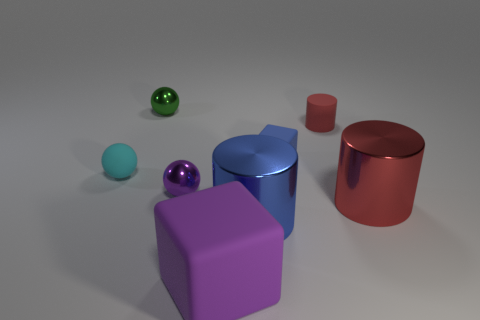Is the material of the large block the same as the small cylinder?
Keep it short and to the point. Yes. There is a rubber thing that is both on the right side of the tiny green object and to the left of the blue metallic thing; what shape is it?
Provide a short and direct response. Cube. There is a cyan thing that is the same material as the small red object; what shape is it?
Your answer should be compact. Sphere. Are there any matte things?
Your answer should be compact. Yes. Is there a green thing in front of the purple thing in front of the purple metal thing?
Offer a very short reply. No. What is the material of the purple thing that is the same shape as the small blue object?
Keep it short and to the point. Rubber. Are there more tiny red matte blocks than tiny red things?
Offer a terse response. No. There is a big block; is its color the same as the small object that is on the right side of the small blue matte thing?
Keep it short and to the point. No. What color is the metal thing that is both in front of the tiny cube and on the left side of the purple matte thing?
Your answer should be compact. Purple. How many other things are made of the same material as the small green object?
Make the answer very short. 3. 